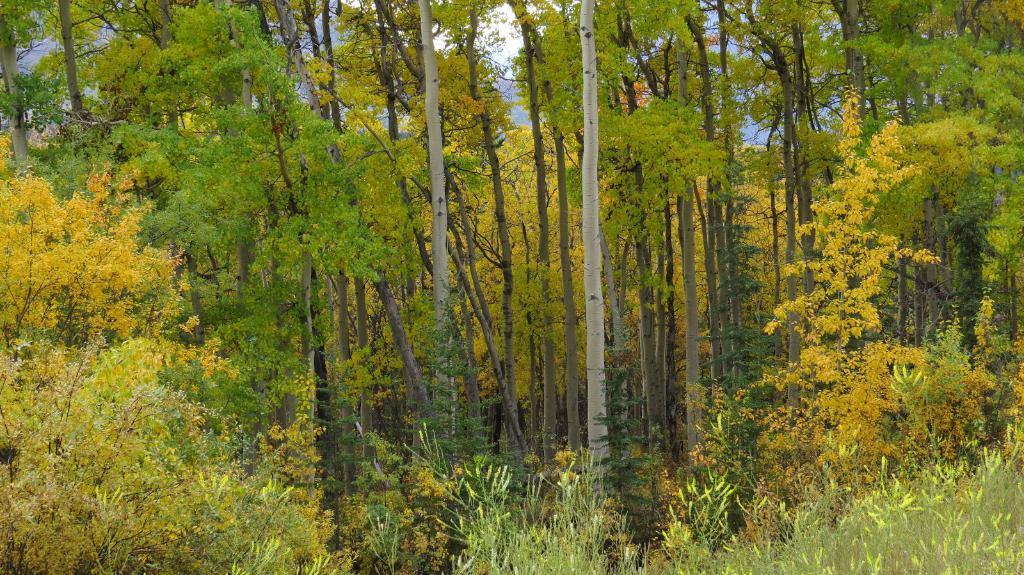Describe this image in one or two sentences. There are plants. Which are having flowers. In the background, there are trees and clouds in the blue sky. 